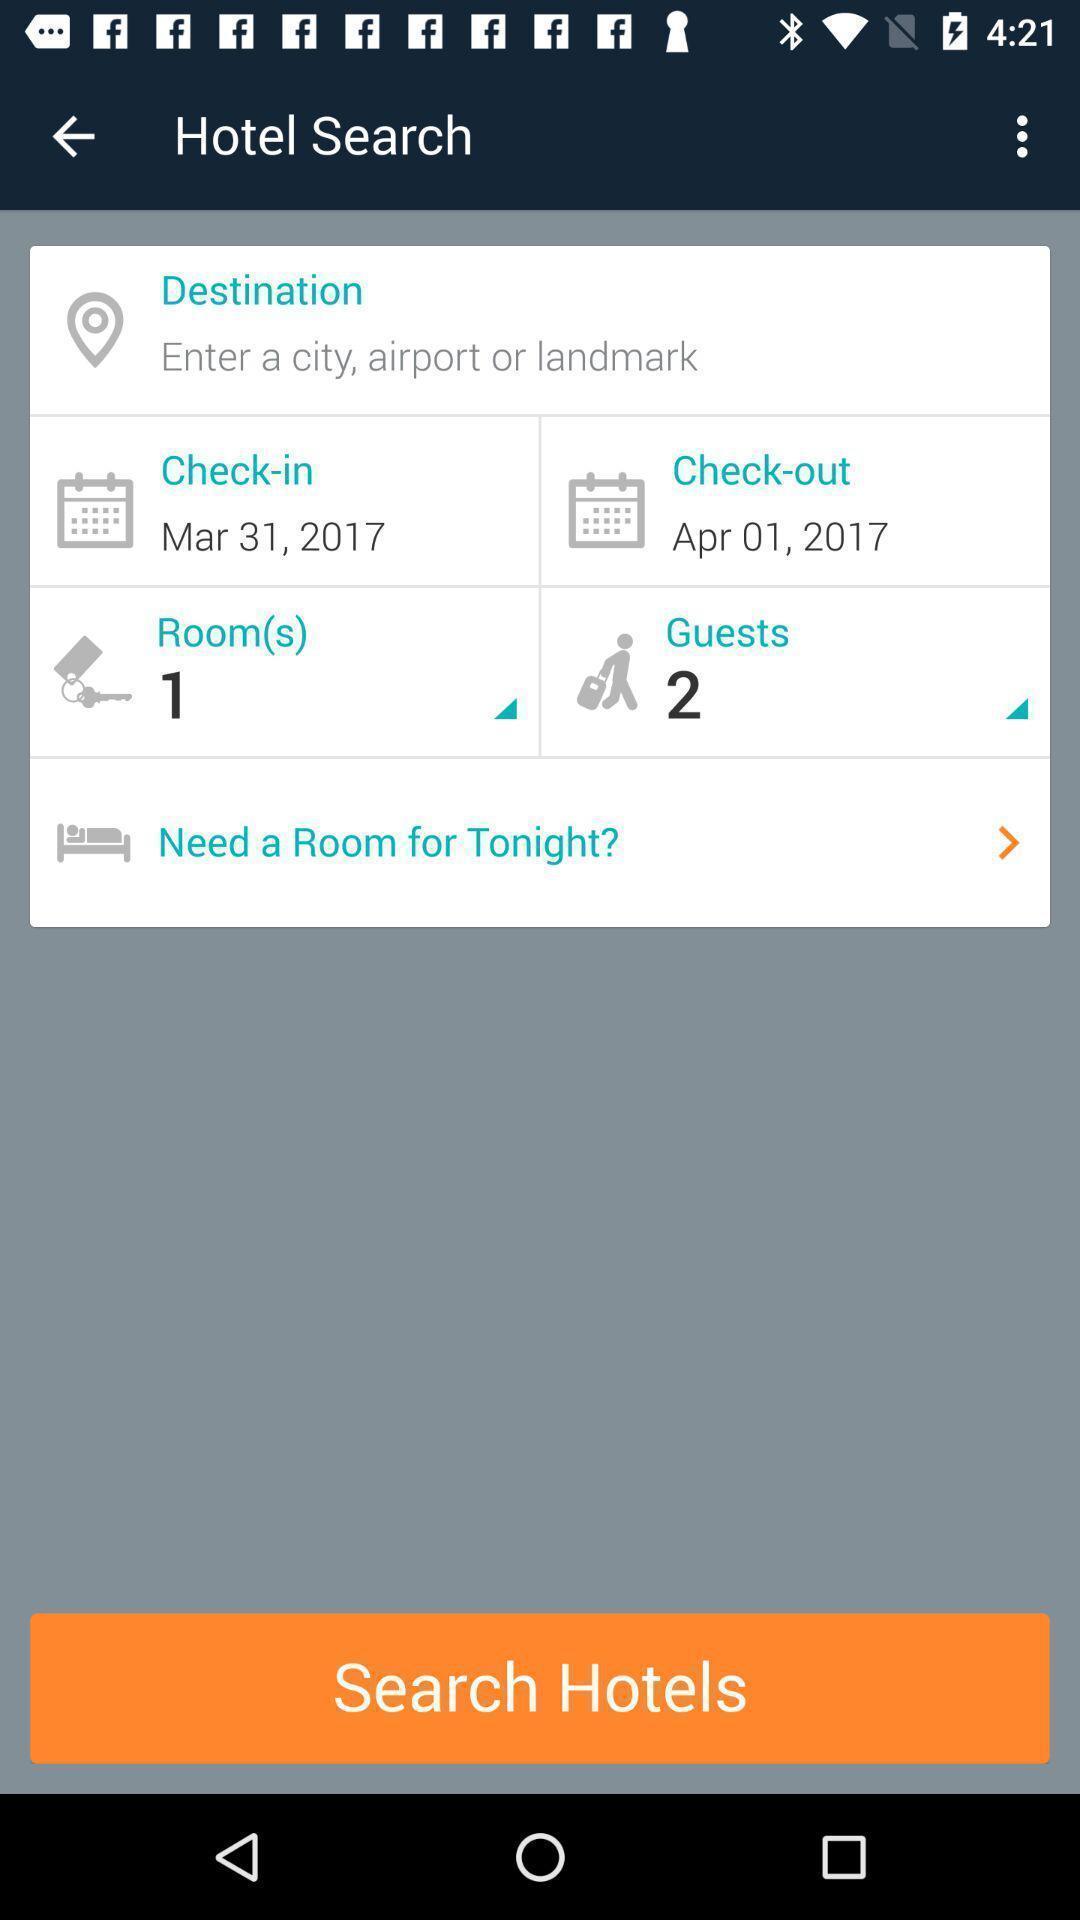Provide a detailed account of this screenshot. Various hotel booking details page displayed of a travel app. 